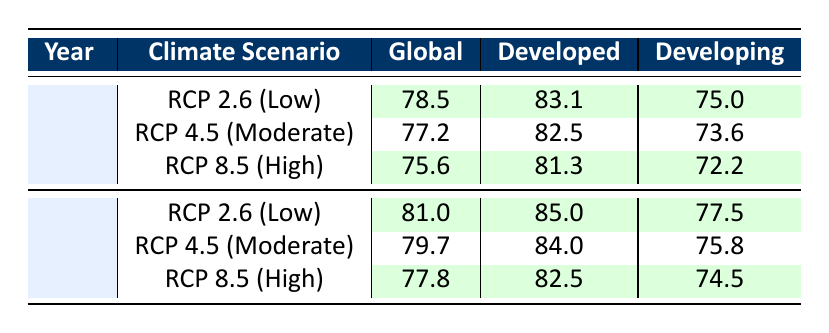What is the life expectancy in 2050 under the RCP 2.6 scenario for developed countries? The life expectancy for developed countries under the RCP 2.6 scenario in 2050 is listed directly in the table. It shows 83.1 years.
Answer: 83.1 How much lower is the global life expectancy in 2100 under the RCP 8.5 scenario compared to the RCP 2.6 scenario? The global life expectancy for RCP 8.5 in 2100 is 77.8, while for RCP 2.6 it is 81.0. The difference is calculated as 81.0 - 77.8 = 3.2 years.
Answer: 3.2 Is the life expectancy for developing countries higher in 2050 or 2100 under the RCP 4.5 scenario? In the table, the life expectancy for developing countries under RCP 4.5 is 73.6 in 2050 and 75.8 in 2100, thus it is higher in 2100.
Answer: Yes What is the average life expectancy for global populations across all scenarios in 2050? The values for global life expectancy in 2050 are 78.5, 77.2, and 75.6. Their sum is 78.5 + 77.2 + 75.6 = 231.3, and the average is 231.3 / 3 = 77.1.
Answer: 77.1 Under which climate scenario is the life expectancy for developing countries the lowest in 2050? Referring to the table, the life expectancy for developing countries is 72.2 under the RCP 8.5 scenario in 2050, which is the lowest when compared to other scenarios of that year.
Answer: RCP 8.5 What is the increase in life expectancy for global populations from 2050 to 2100 under the RCP 2.6 scenario? For RCP 2.6, the global life expectancy is 78.5 in 2050 and rises to 81.0 in 2100. To find the increase, we calculate 81.0 - 78.5 = 2.5 years.
Answer: 2.5 Is the life expectancy for developed countries under the RCP 4.5 scenario in 2100 higher than 80 years? Checking the table, the life expectancy under RCP 4.5 for developed countries in 2100 is 84.0 years, which is higher than 80 years.
Answer: Yes What is the difference in life expectancy for global populations between the RCP 4.5 scenario and the RCP 8.5 scenario in 2050? Referring to the table, the life expectancy under RCP 4.5 is 77.2 and under RCP 8.5 is 75.6. The difference is calculated as 77.2 - 75.6 = 1.6 years.
Answer: 1.6 